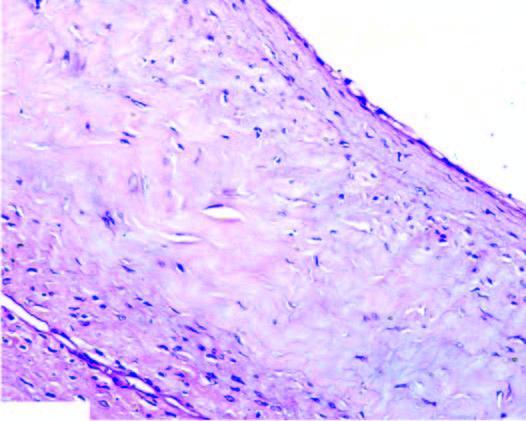s the biopsy composed of dense connective tissue lined internally by flattened lining?
Answer the question using a single word or phrase. No 